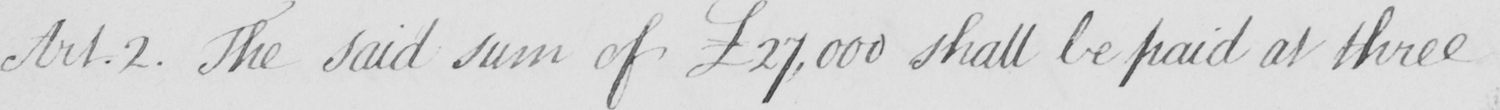Can you read and transcribe this handwriting? Art.2 . The said sum of £27,000 shall be paid at three 